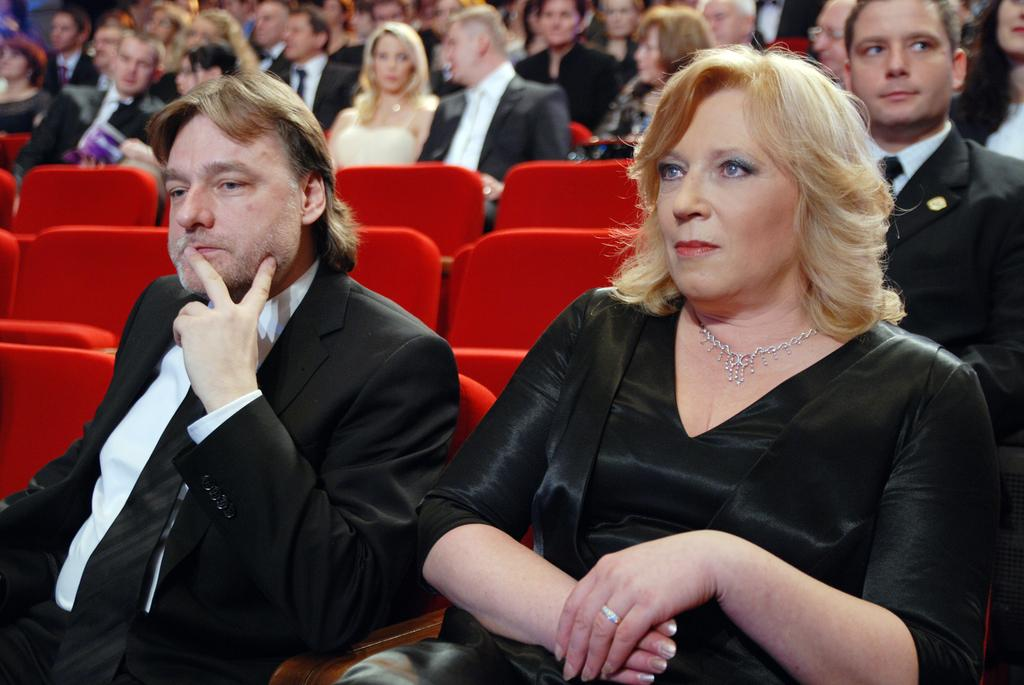How many people are in the image? There are many persons in the image. What are the persons doing in the image? The persons are sitting on chairs. What type of stem can be seen growing from the ocean in the image? There is no stem or ocean present in the image; it features many persons sitting on chairs. 